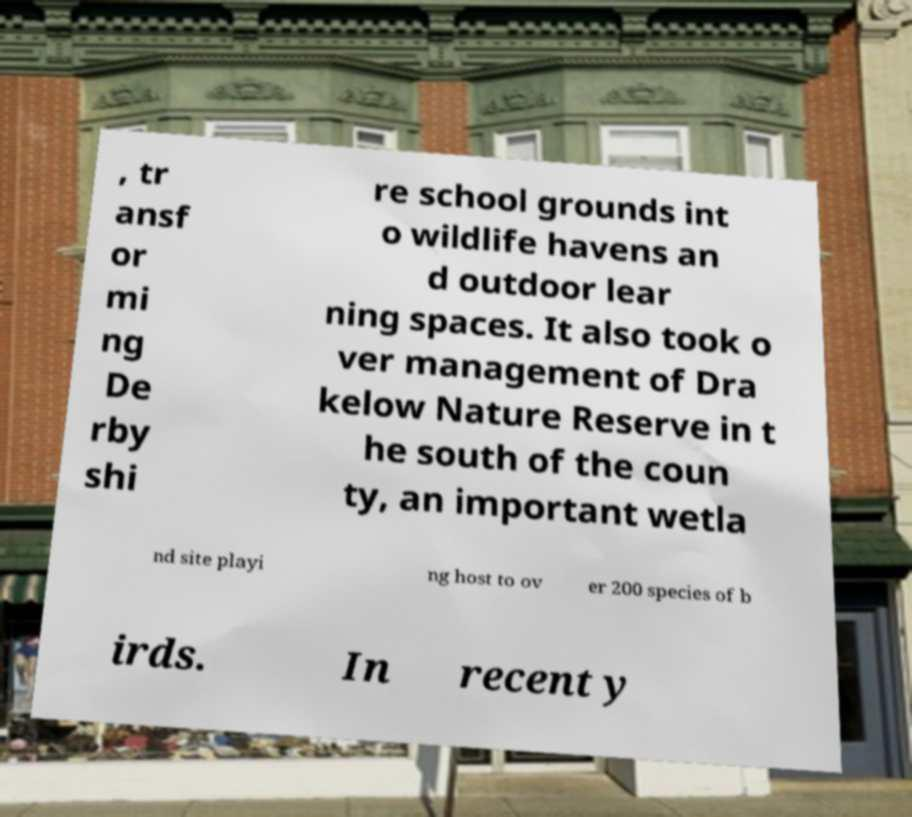What messages or text are displayed in this image? I need them in a readable, typed format. , tr ansf or mi ng De rby shi re school grounds int o wildlife havens an d outdoor lear ning spaces. It also took o ver management of Dra kelow Nature Reserve in t he south of the coun ty, an important wetla nd site playi ng host to ov er 200 species of b irds. In recent y 